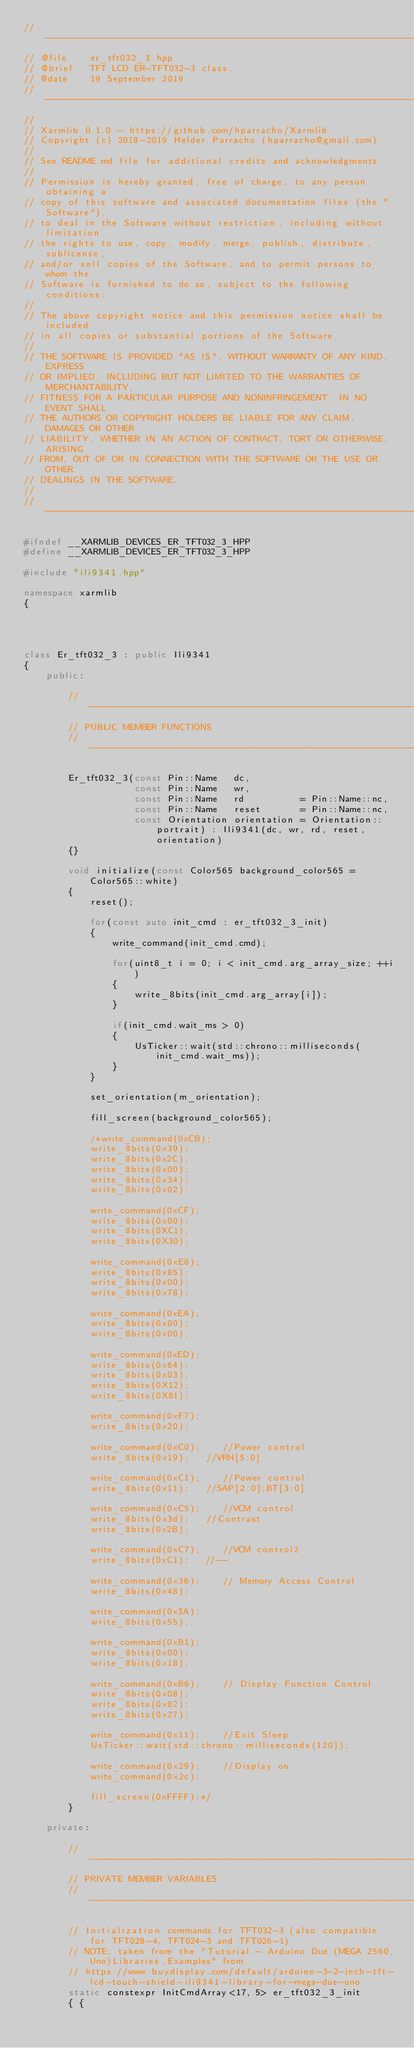<code> <loc_0><loc_0><loc_500><loc_500><_C++_>// ----------------------------------------------------------------------------
// @file    er_tft032_3.hpp
// @brief   TFT LCD ER-TFT032-3 class.
// @date    19 September 2019
// ----------------------------------------------------------------------------
//
// Xarmlib 0.1.0 - https://github.com/hparracho/Xarmlib
// Copyright (c) 2018-2019 Helder Parracho (hparracho@gmail.com)
//
// See README.md file for additional credits and acknowledgments.
//
// Permission is hereby granted, free of charge, to any person obtaining a
// copy of this software and associated documentation files (the "Software"),
// to deal in the Software without restriction, including without limitation
// the rights to use, copy, modify, merge, publish, distribute, sublicense,
// and/or sell copies of the Software, and to permit persons to whom the
// Software is furnished to do so, subject to the following conditions:
//
// The above copyright notice and this permission notice shall be included
// in all copies or substantial portions of the Software.
//
// THE SOFTWARE IS PROVIDED "AS IS", WITHOUT WARRANTY OF ANY KIND, EXPRESS
// OR IMPLIED, INCLUDING BUT NOT LIMITED TO THE WARRANTIES OF MERCHANTABILITY,
// FITNESS FOR A PARTICULAR PURPOSE AND NONINFRINGEMENT. IN NO EVENT SHALL
// THE AUTHORS OR COPYRIGHT HOLDERS BE LIABLE FOR ANY CLAIM, DAMAGES OR OTHER
// LIABILITY, WHETHER IN AN ACTION OF CONTRACT, TORT OR OTHERWISE, ARISING
// FROM, OUT OF OR IN CONNECTION WITH THE SOFTWARE OR THE USE OR OTHER
// DEALINGS IN THE SOFTWARE.
//
// ----------------------------------------------------------------------------

#ifndef __XARMLIB_DEVICES_ER_TFT032_3_HPP
#define __XARMLIB_DEVICES_ER_TFT032_3_HPP

#include "ili9341.hpp"

namespace xarmlib
{




class Er_tft032_3 : public Ili9341
{
    public:

        // --------------------------------------------------------------------
        // PUBLIC MEMBER FUNCTIONS
        // --------------------------------------------------------------------

        Er_tft032_3(const Pin::Name   dc,
                    const Pin::Name   wr,
                    const Pin::Name   rd          = Pin::Name::nc,
                    const Pin::Name   reset       = Pin::Name::nc,
                    const Orientation orientation = Orientation::portrait) : Ili9341(dc, wr, rd, reset, orientation)
        {}

        void initialize(const Color565 background_color565 = Color565::white)
        {
            reset();

            for(const auto init_cmd : er_tft032_3_init)
            {
                write_command(init_cmd.cmd);

                for(uint8_t i = 0; i < init_cmd.arg_array_size; ++i)
                {
                    write_8bits(init_cmd.arg_array[i]);
                }

                if(init_cmd.wait_ms > 0)
                {
                    UsTicker::wait(std::chrono::milliseconds(init_cmd.wait_ms));
                }
            }

            set_orientation(m_orientation);

            fill_screen(background_color565);

            /*write_command(0xCB);
            write_8bits(0x39);
            write_8bits(0x2C);
            write_8bits(0x00);
            write_8bits(0x34);
            write_8bits(0x02);

            write_command(0xCF);
            write_8bits(0x00);
            write_8bits(0XC1);
            write_8bits(0X30);

            write_command(0xE8);
            write_8bits(0x85);
            write_8bits(0x00);
            write_8bits(0x78);

            write_command(0xEA);
            write_8bits(0x00);
            write_8bits(0x00);

            write_command(0xED);
            write_8bits(0x64);
            write_8bits(0x03);
            write_8bits(0X12);
            write_8bits(0X81);

            write_command(0xF7);
            write_8bits(0x20);

            write_command(0xC0);    //Power control
            write_8bits(0x19);   //VRH[5:0]

            write_command(0xC1);    //Power control
            write_8bits(0x11);   //SAP[2:0];BT[3:0]

            write_command(0xC5);    //VCM control
            write_8bits(0x3d);   //Contrast
            write_8bits(0x2B);

            write_command(0xC7);    //VCM control2
            write_8bits(0xC1);   //--

            write_command(0x36);    // Memory Access Control
            write_8bits(0x48);

            write_command(0x3A);
            write_8bits(0x55);

            write_command(0xB1);
            write_8bits(0x00);
            write_8bits(0x18);

            write_command(0xB6);    // Display Function Control
            write_8bits(0x08);
            write_8bits(0x82);
            write_8bits(0x27);

            write_command(0x11);    //Exit Sleep
            UsTicker::wait(std::chrono::milliseconds(120));

            write_command(0x29);    //Display on
            write_command(0x2c);

            fill_screen(0xFFFF);*/
        }

    private:

        // --------------------------------------------------------------------
        // PRIVATE MEMBER VARIABLES
        // --------------------------------------------------------------------

        // Initialization commands for TFT032-3 (also compatible for TFT028-4, TFT024-3 and TFT026-1)
        // NOTE: taken from the "Tutorial - Arduino Due (MEGA 2560,Uno)Libraries,Examples" from
        // https://www.buydisplay.com/default/arduino-3-2-inch-tft-lcd-touch-shield-ili9341-library-for-mega-due-uno
        static constexpr InitCmdArray<17, 5> er_tft032_3_init
        { {</code> 